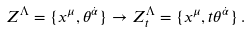<formula> <loc_0><loc_0><loc_500><loc_500>Z ^ { \Lambda } = \{ x ^ { \mu } , \theta ^ { \dot { \alpha } } \} \rightarrow Z _ { t } ^ { \Lambda } = \{ x ^ { \mu } , t \theta ^ { \dot { \alpha } } \} \, .</formula> 